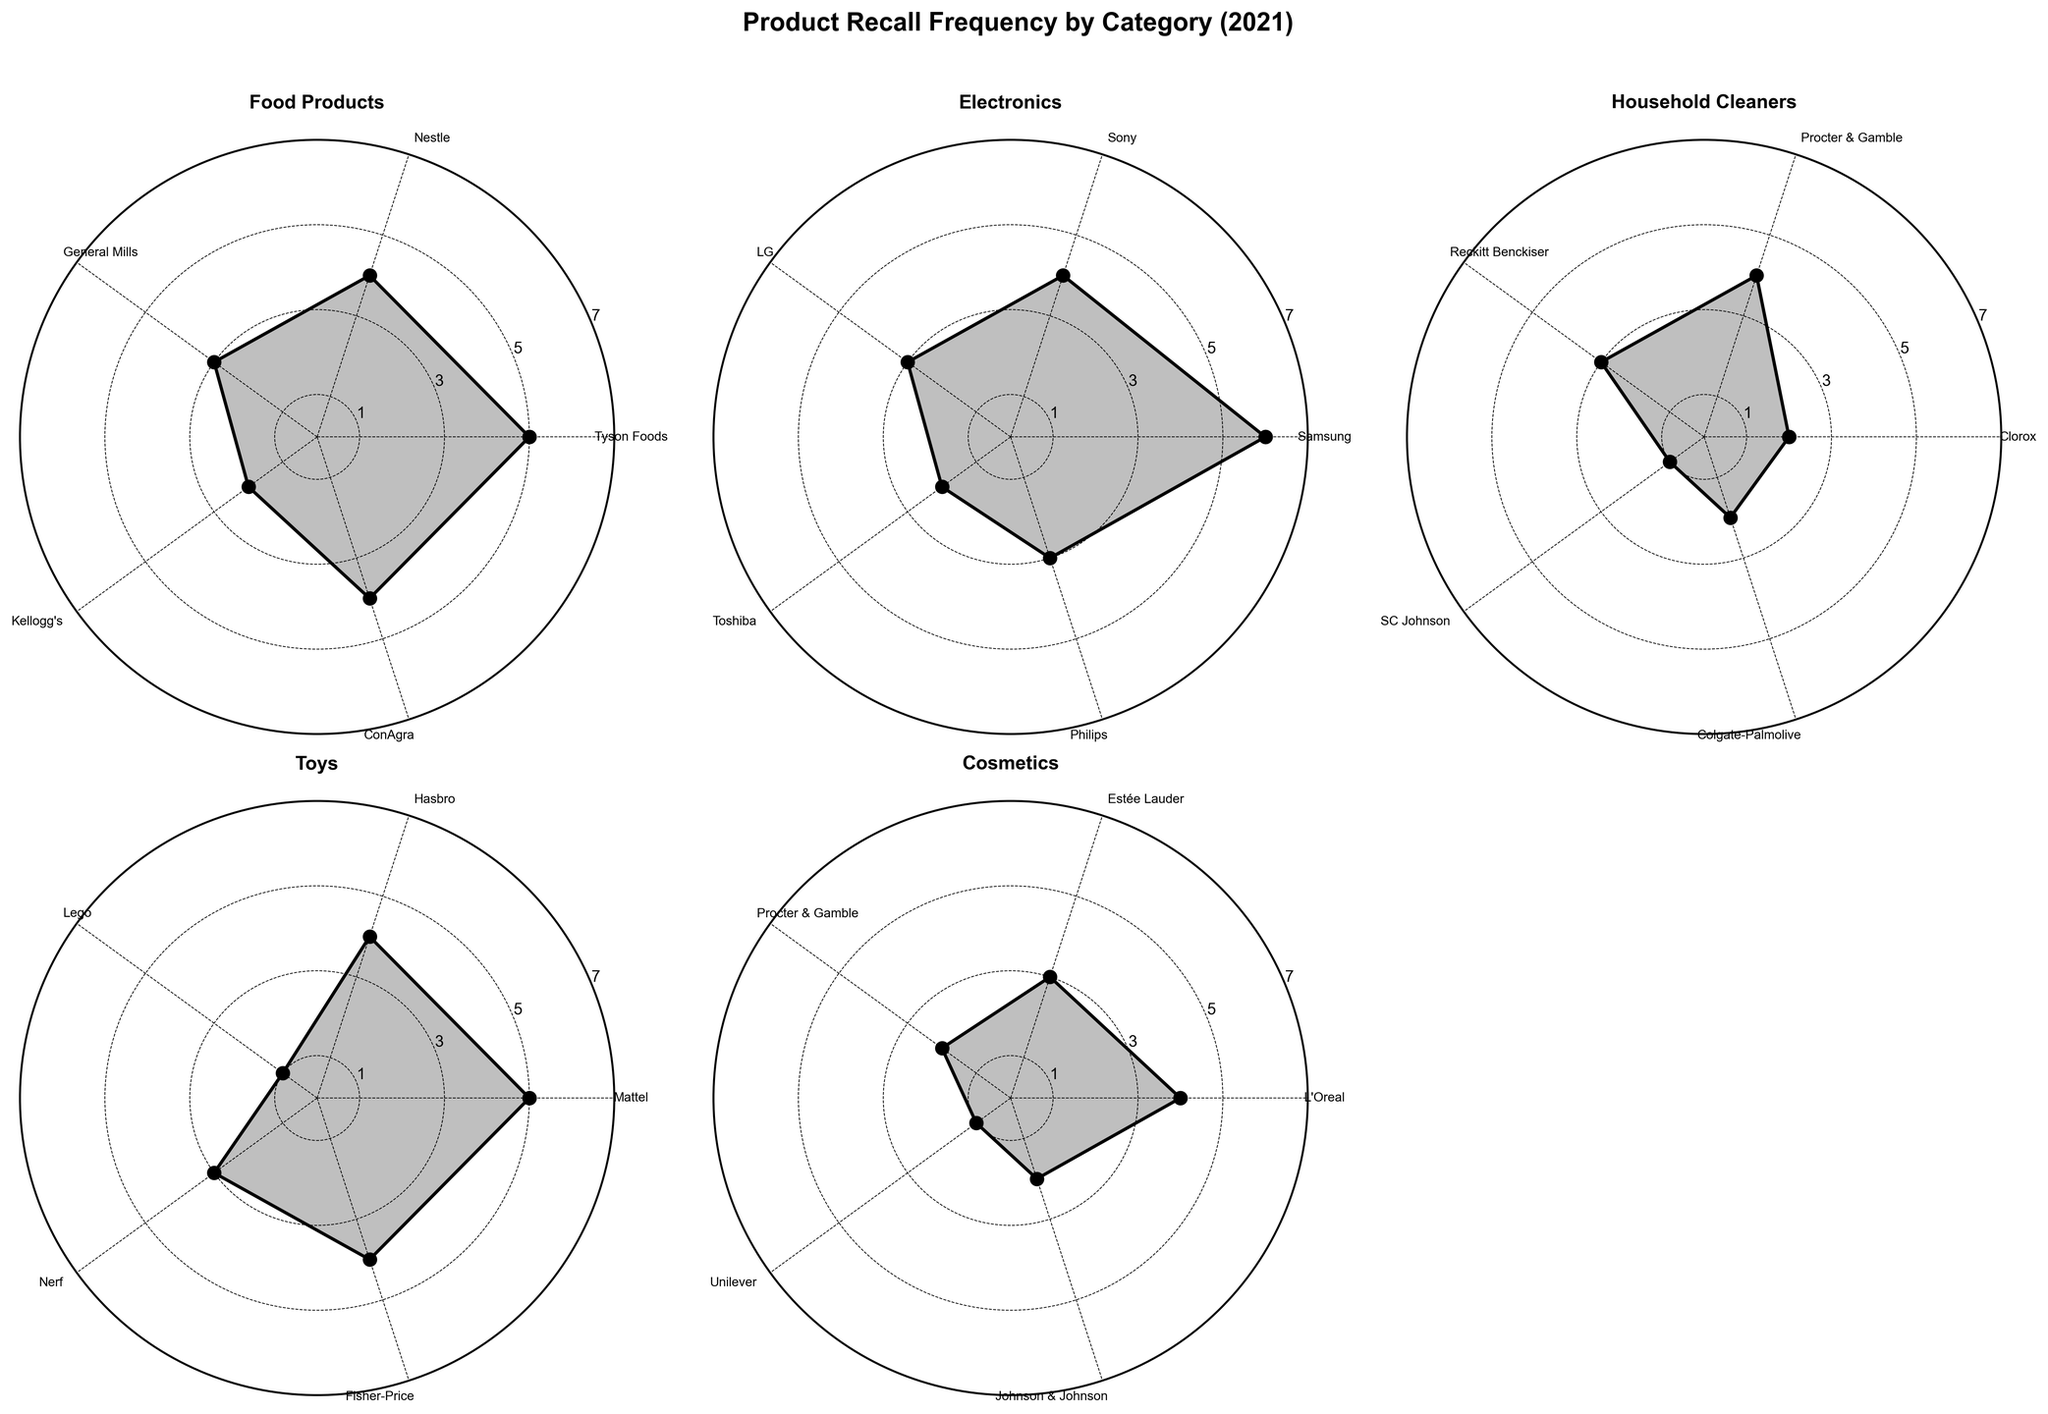What is the title of the figure? The title of the figure is displayed above the subplots.
Answer: Product Recall Frequency by Category (2021) Which category has the highest recall frequency for any company in 2021? The largest value in any subplot represents the highest recall frequency. Refer to each subplot and identify the highest point on the radar chart.
Answer: Electronics How many companies are represented in the Household Cleaners category? The radar chart for Household Cleaners shows distinct labeled points around its circumference. Count these points to determine the number of companies.
Answer: 5 Which company had the highest recall frequency in the Toys category? Locate the subplot for Toys and identify the company labeled at the highest point on the radar chart.
Answer: Mattel What is the average recall frequency in the Food Products category? Sum the recall frequencies for all companies in the Food Products category and divide by the number of companies. The data values are: Tyson Foods (5), Nestle (4), General Mills (3), Kellogg's (2), ConAgra (4). Calculation: (5 + 4 + 3 + 2 + 4) / 5 = 18 / 5 = 3.6
Answer: 3.6 How does the recall frequency for Procter & Gamble compare between the Household Cleaners and Cosmetics categories? Locate the radar charts for both Household Cleaners and Cosmetics. Identify the recall frequencies for Procter & Gamble in both subplots and compare these values. Household Cleaners: 4, Cosmetics: 2. Procter & Gamble had a higher recall frequency in Household Cleaners.
Answer: Higher in Household Cleaners Which category has the lowest variability in recall frequencies? Evaluate the spread of points in each subplot. The category with the least variation has points clustered closely around a single value with minimal deviation.
Answer: Cosmetics What is the total recall frequency for all companies in the Electronics category? Sum the recall frequencies for each company in the Electronics category. The values are: Samsung (6), Sony (4), LG (3), Toshiba (2), Philips (3). Calculation: 6 + 4 + 3 + 2 + 3 = 18
Answer: 18 Which company had the lowest recall frequency in the Cosmetics category? In the Cosmetics radar chart, find the company labeled at the lowest point on the chart.
Answer: Unilever Which categories have companies with recall frequencies of exactly 4 in 2021? Check each subplot for companies that have a data point on the 4 mark.
Answer: Food Products, Household Cleaners, Toys, Cosmetics 